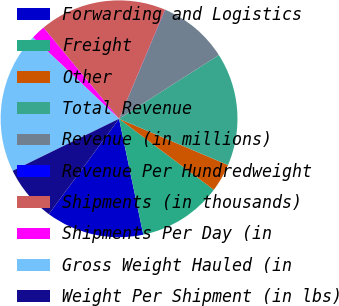Convert chart. <chart><loc_0><loc_0><loc_500><loc_500><pie_chart><fcel>Forwarding and Logistics<fcel>Freight<fcel>Other<fcel>Total Revenue<fcel>Revenue (in millions)<fcel>Revenue Per Hundredweight<fcel>Shipments (in thousands)<fcel>Shipments Per Day (in<fcel>Gross Weight Hauled (in<fcel>Weight Per Shipment (in lbs)<nl><fcel>13.38%<fcel>11.48%<fcel>3.85%<fcel>15.43%<fcel>9.57%<fcel>0.03%<fcel>17.37%<fcel>1.94%<fcel>19.28%<fcel>7.66%<nl></chart> 